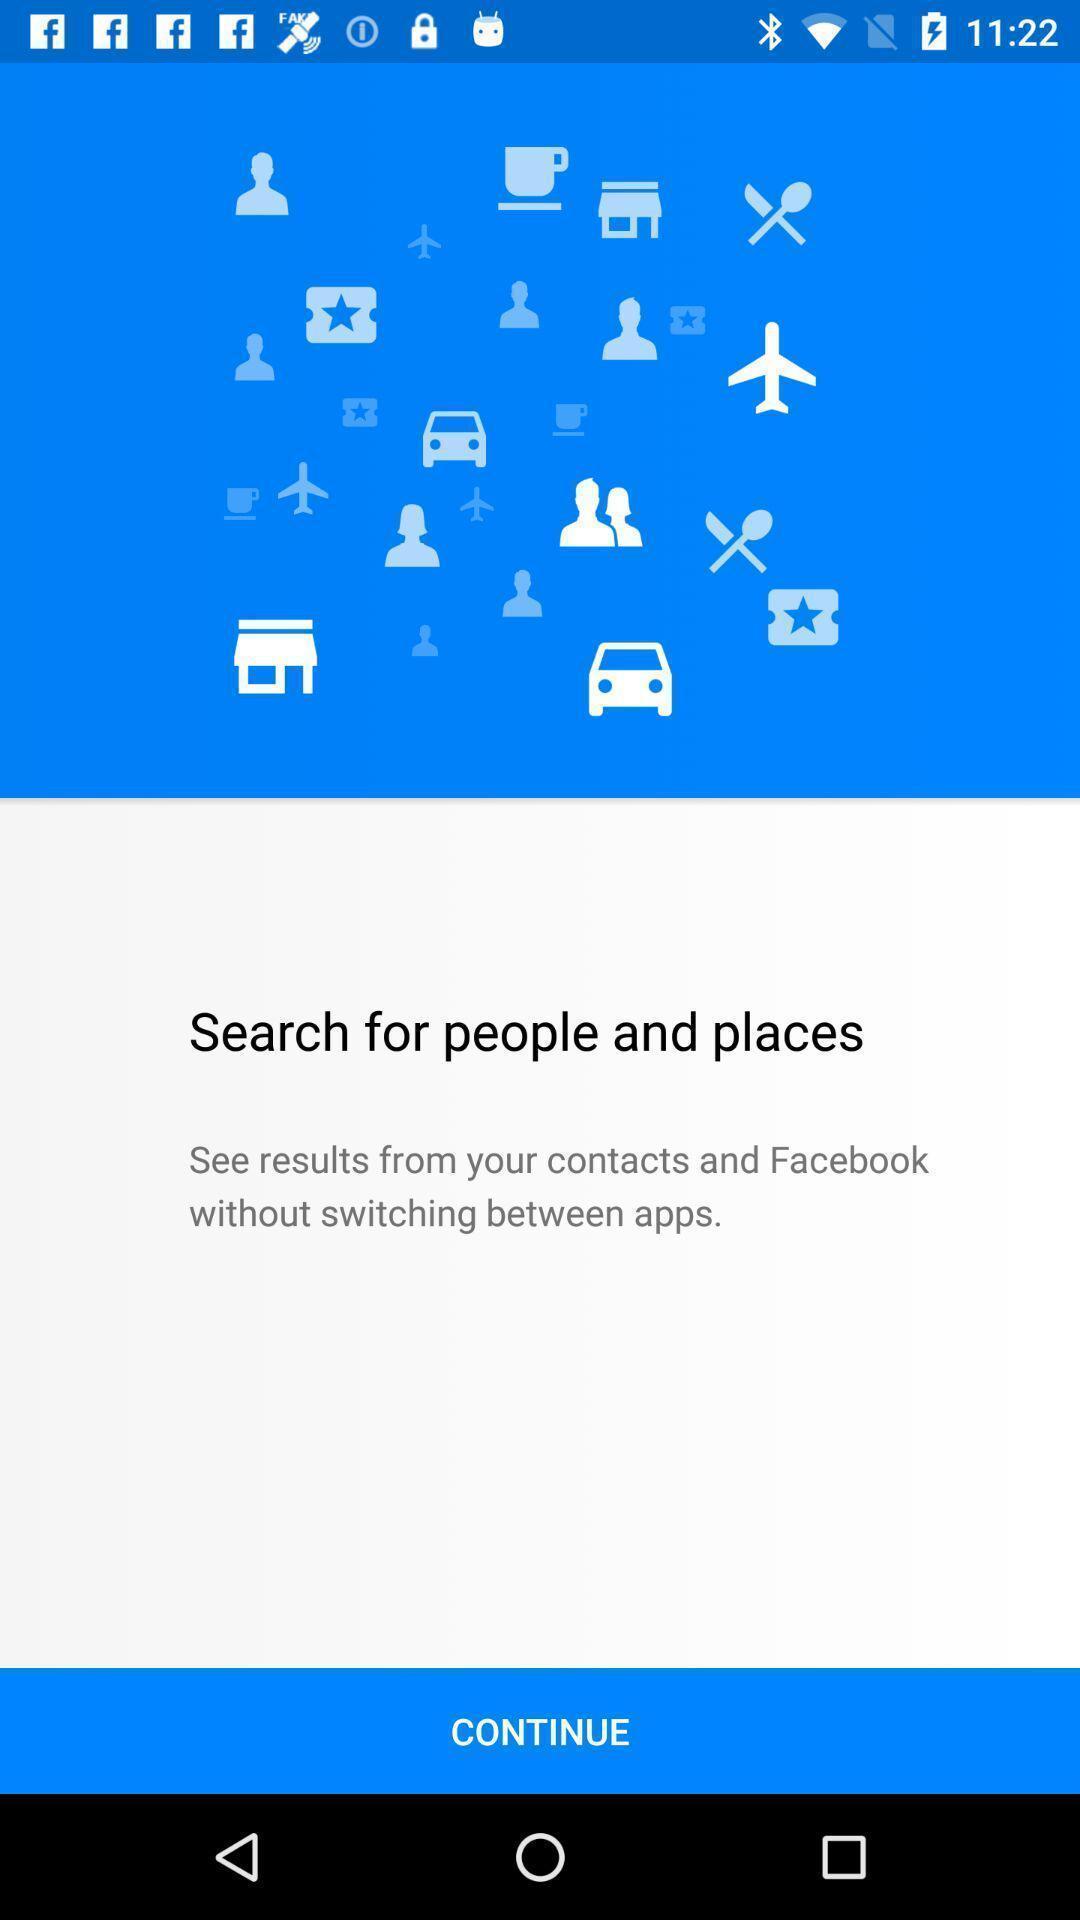Describe the visual elements of this screenshot. Welcome page. 